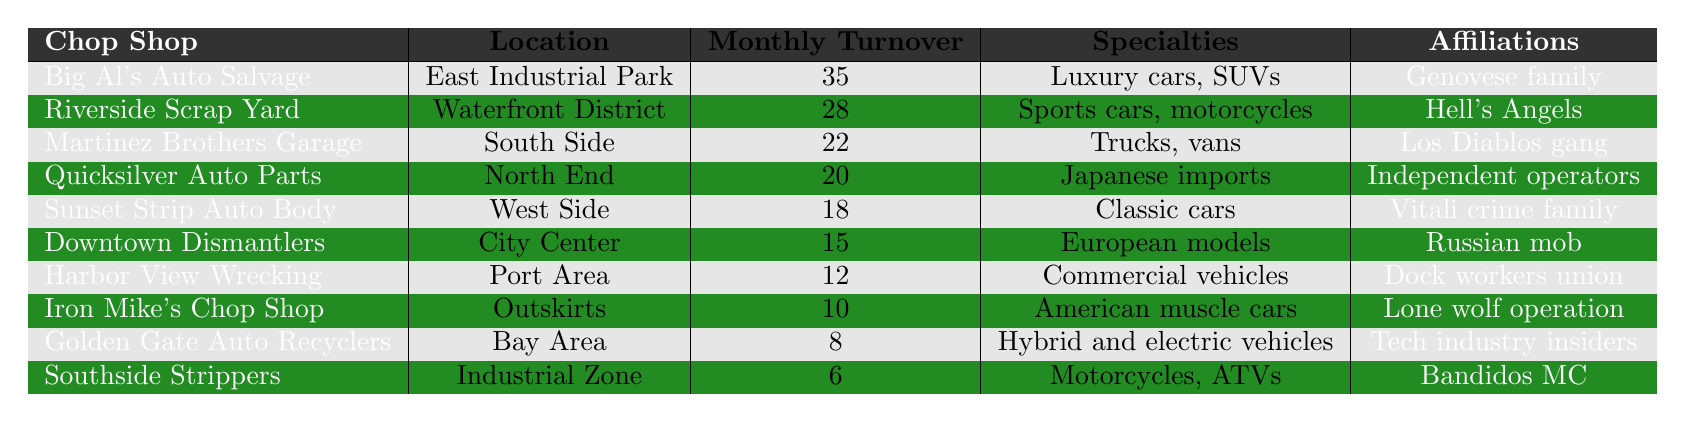What is the estimated monthly turnover of Big Al's Auto Salvage? The table lists Big Al's Auto Salvage with an estimated monthly turnover of 35 vehicles.
Answer: 35 Which chop shop specializes in luxury cars and SUVs? The table indicates that Big Al's Auto Salvage specializes in luxury cars and SUVs.
Answer: Big Al's Auto Salvage What is the total estimated monthly turnover of the top three chop shops? The top three chop shops and their turnovers are: Big Al's Auto Salvage (35), Riverside Scrap Yard (28), and Martinez Brothers Garage (22). Summing these gives 35 + 28 + 22 = 85.
Answer: 85 How many chop shops have estimated monthly turnovers greater than 20? The chop shops with turnovers greater than 20 are Big Al's Auto Salvage (35), Riverside Scrap Yard (28), and Martinez Brothers Garage (22), totaling 3 shops.
Answer: 3 Which chop shop located in the Port Area has a monthly turnover of 12? The table shows that Harbor View Wrecking, located in the Port Area, has an estimated monthly turnover of 12.
Answer: Harbor View Wrecking Is there a chop shop affiliated with the Hell's Angels? Looking at the affiliations, Riverside Scrap Yard is known to have ties to the Hell's Angels.
Answer: Yes What is the average estimated monthly turnover for the chop shops listed? To find the average, sum all turnovers: 35 + 28 + 22 + 20 + 18 + 15 + 12 + 10 + 8 + 6 =  164. There are 10 chop shops, so the average is 164 / 10 = 16.4.
Answer: 16.4 Which chop shop has the lowest estimated monthly turnover, and what is that turnover? Southside Strippers has the lowest turnover at 6, as identified in the table.
Answer: Southside Strippers, 6 How many chop shops are affiliated with crime families? Crime family affiliations are present with Big Al's Auto Salvage (Genovese family), Sunset Strip Auto Body (Vitali crime family), and Riverside Scrap Yard (Hell's Angels). This totals 3 chop shops.
Answer: 3 Which chop shop specializes in hybrid and electric vehicles? Golden Gate Auto Recyclers is specifically noted for its specialty in hybrid and electric vehicles.
Answer: Golden Gate Auto Recyclers 